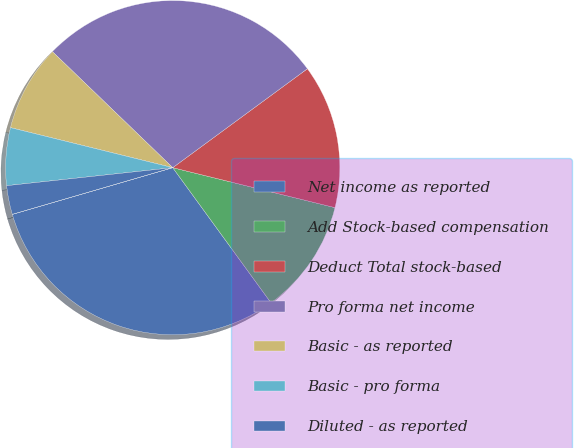Convert chart to OTSL. <chart><loc_0><loc_0><loc_500><loc_500><pie_chart><fcel>Net income as reported<fcel>Add Stock-based compensation<fcel>Deduct Total stock-based<fcel>Pro forma net income<fcel>Basic - as reported<fcel>Basic - pro forma<fcel>Diluted - as reported<fcel>Diluted - proforma<nl><fcel>30.5%<fcel>11.15%<fcel>13.93%<fcel>27.71%<fcel>8.36%<fcel>5.57%<fcel>2.79%<fcel>0.0%<nl></chart> 